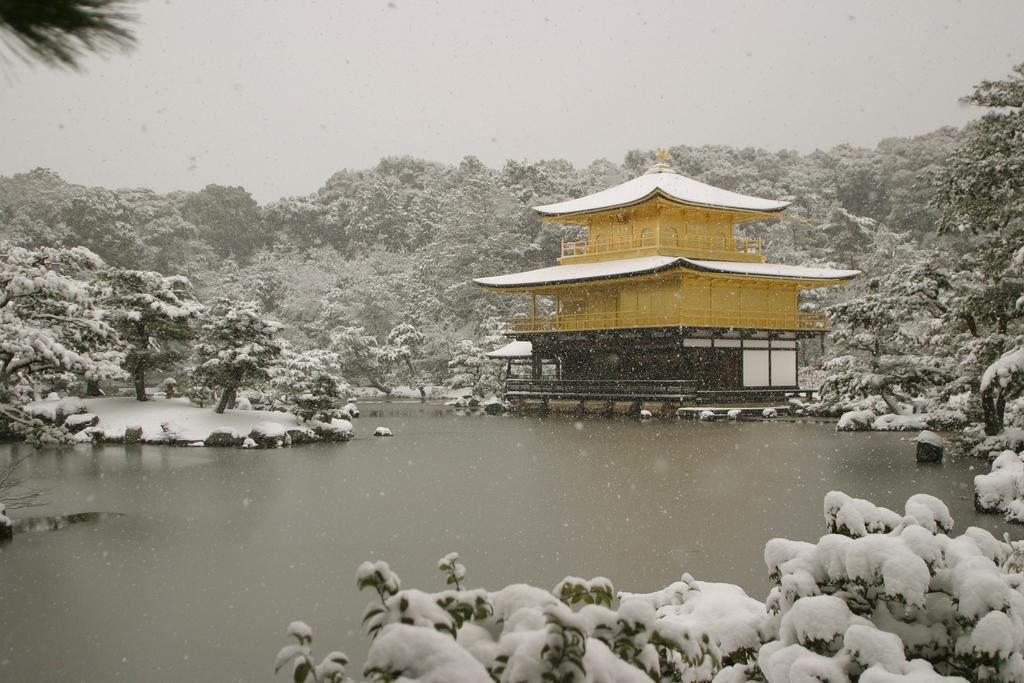What type of activity are the children engaged in within the image? The children are playing in a playground. What specific playground equipment can be seen in the image? There is a slide, a swing, and a seesaw in the playground. Are there any other structures or features in the playground? The provided facts do not mention any other structures or features in the playground. Where is the meeting place for the children to discuss their playground strategies? The provided facts do not mention a meeting place for the children to discuss their playground strategies. What type of jewel can be seen hanging from the swing in the image? There is no jewel hanging from the swing in the image; it only features playground equipment. 